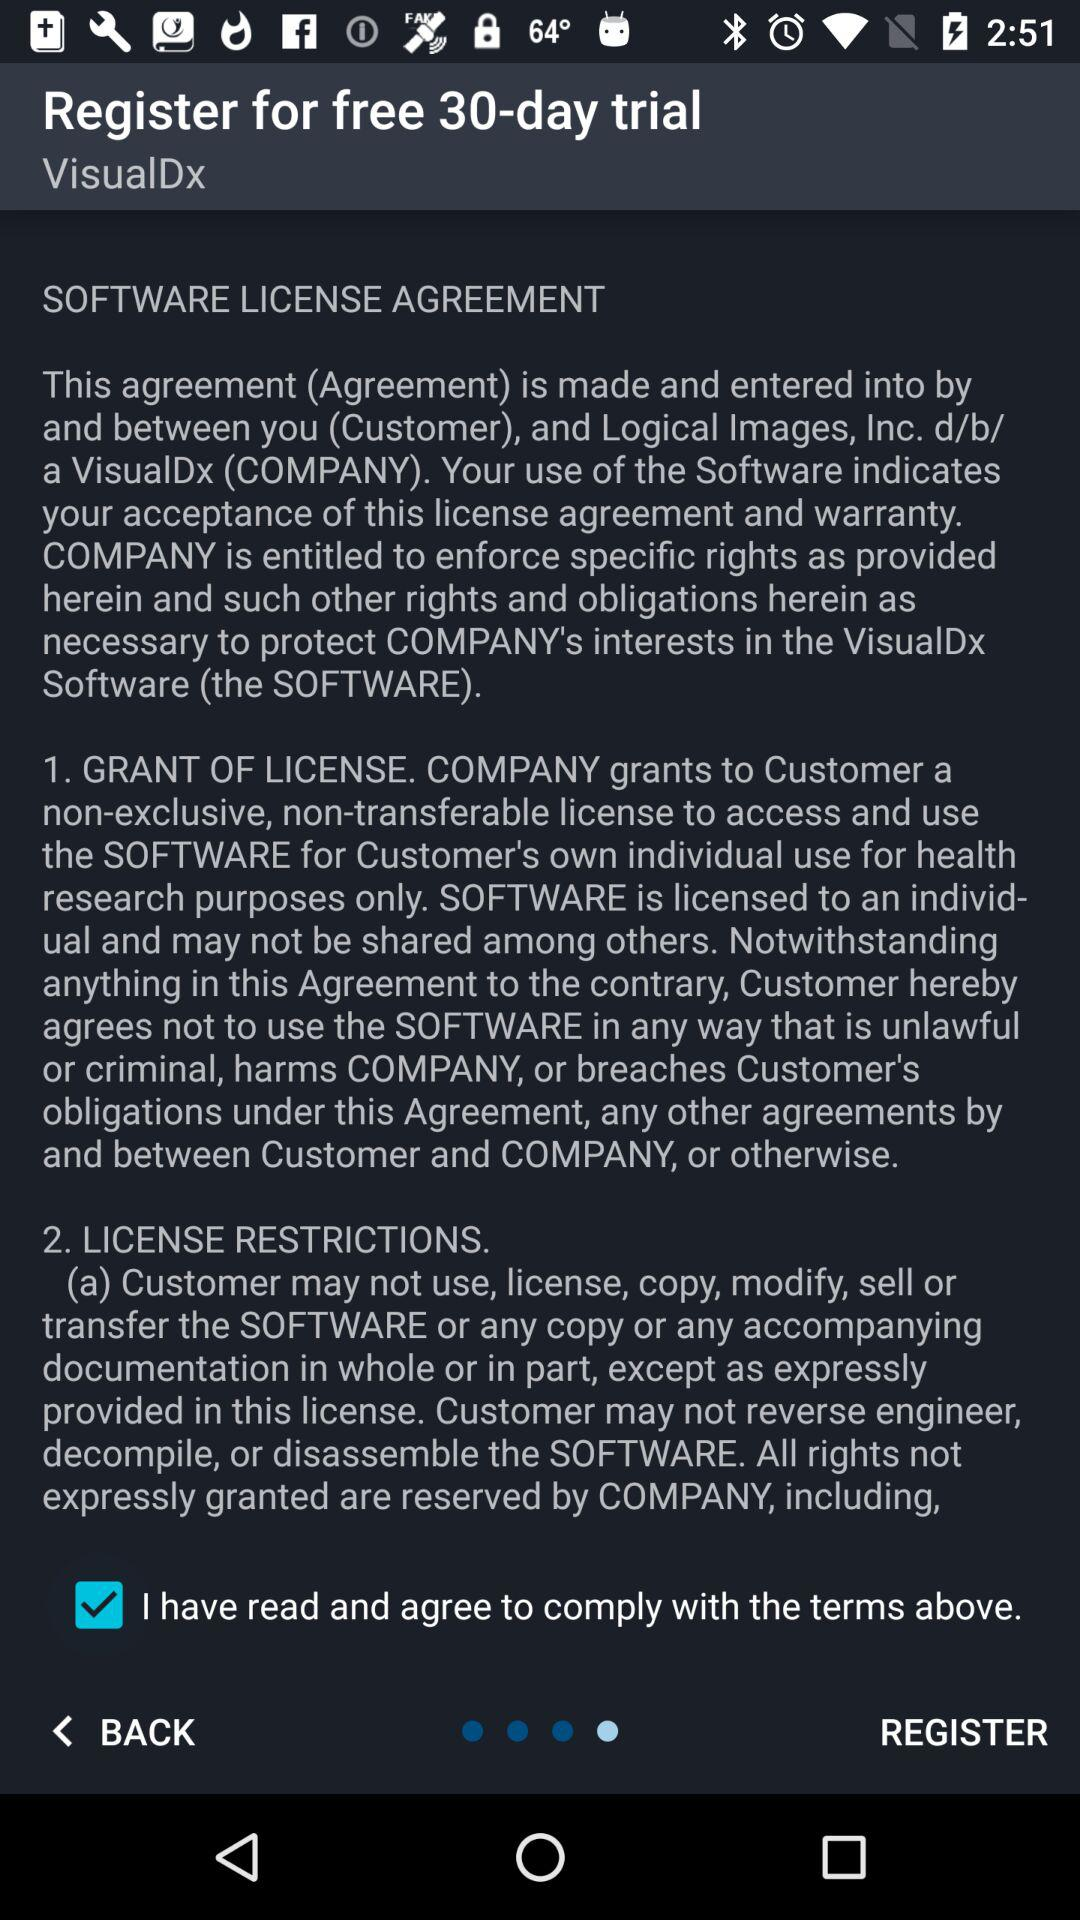For how many days will the free trial last? The free trial will last for 30 days. 